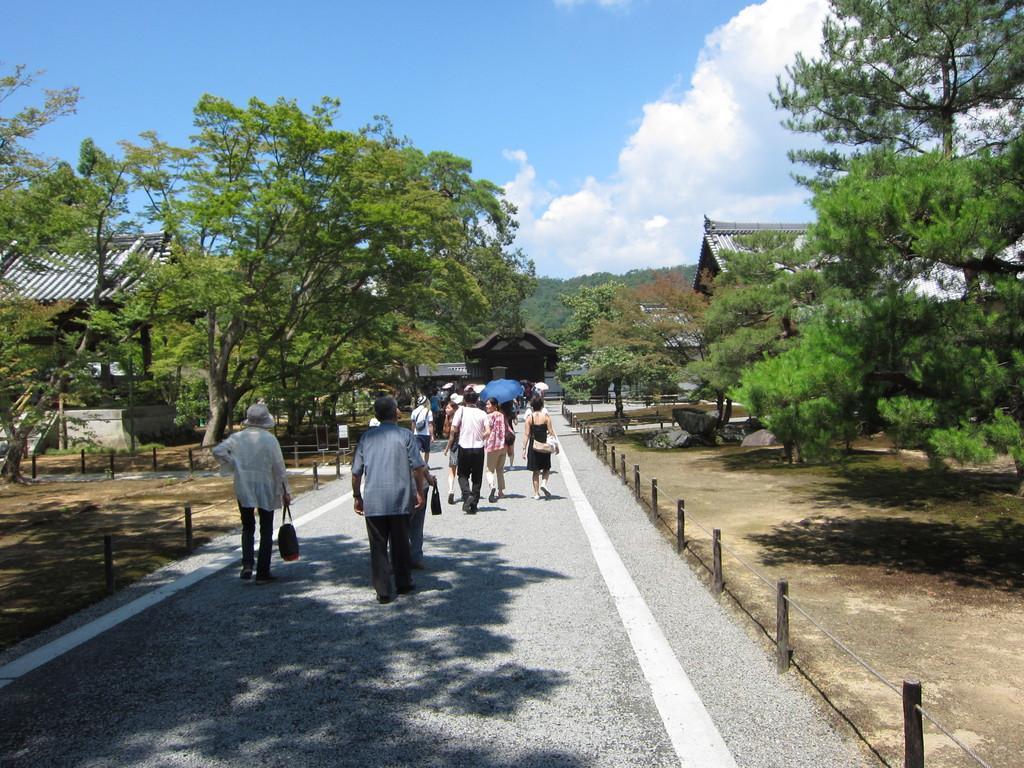Please provide a concise description of this image. In this picture there are buildings and trees and there are group of people walking on the road and there is a person holding the umbrella and there is a railing beside the road. At the top there is sky and there are clouds. At the bottom there is a road and there are rocks. 